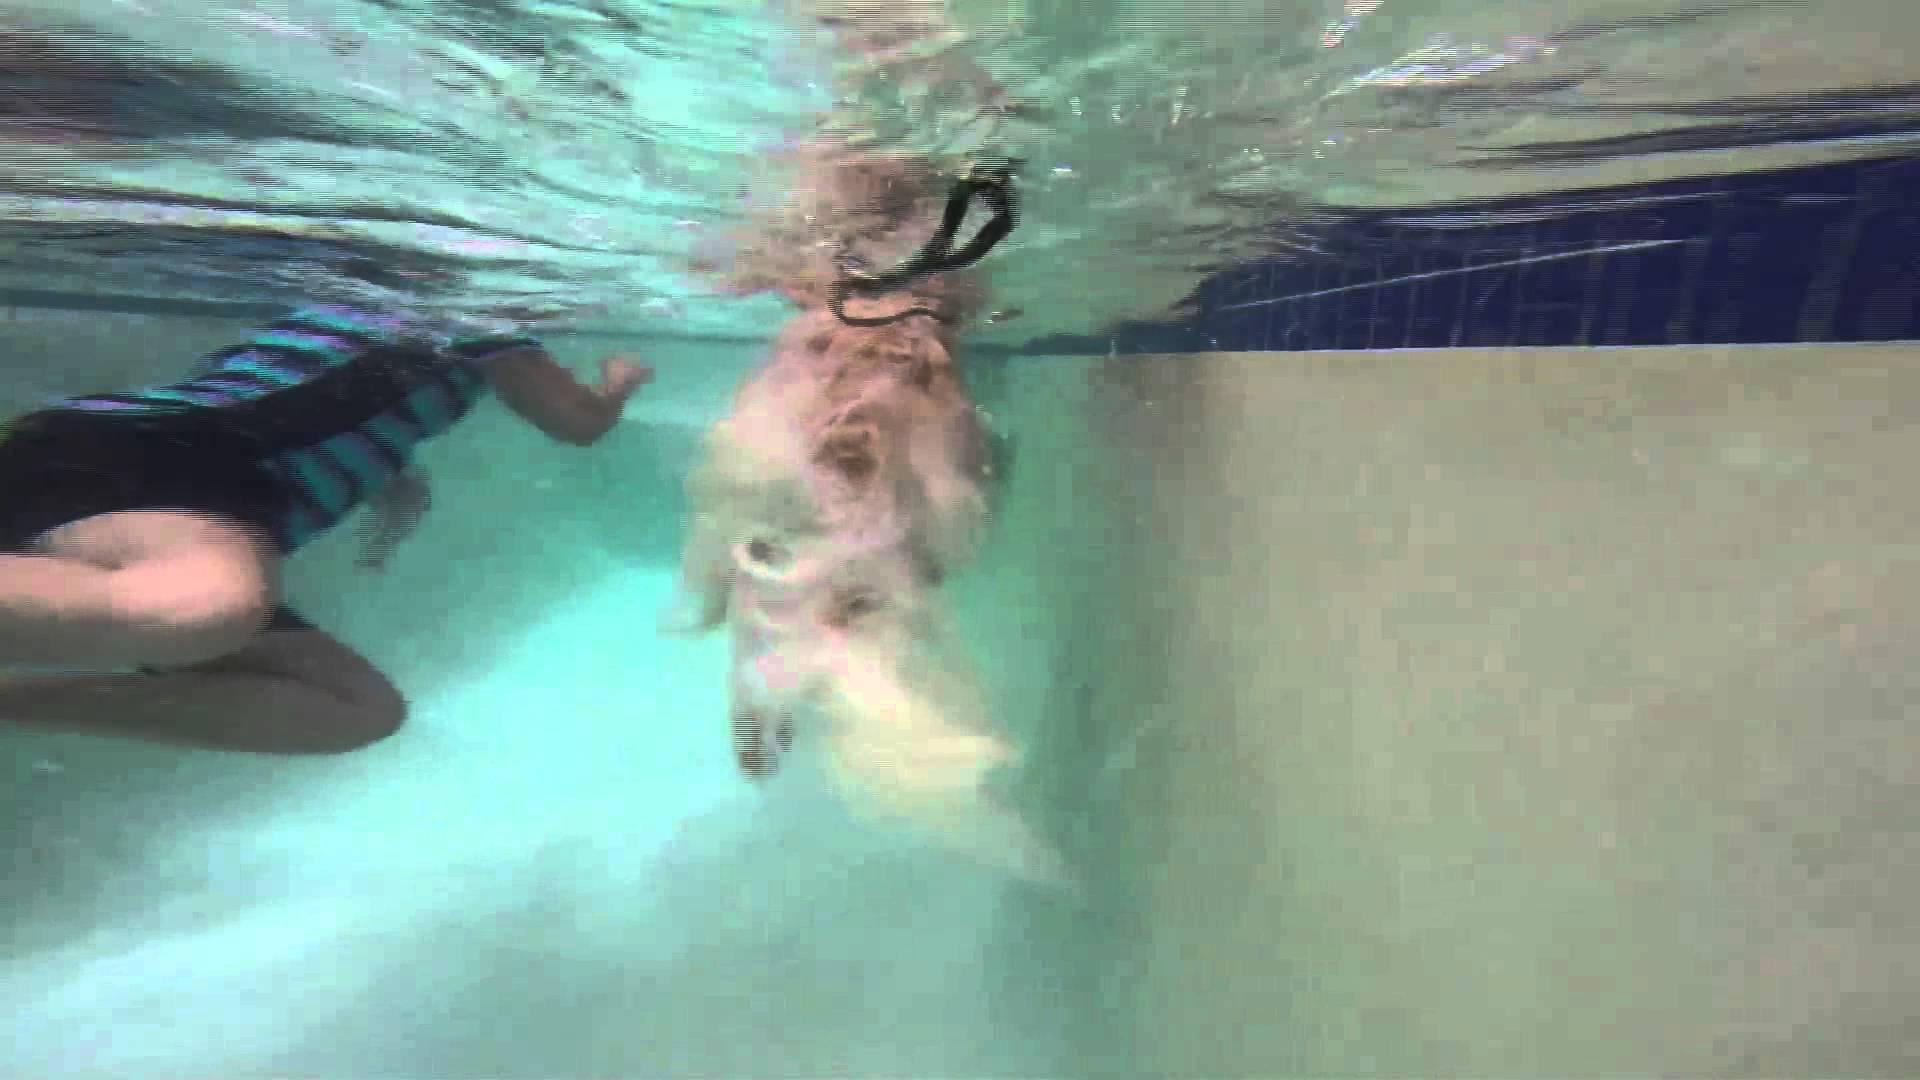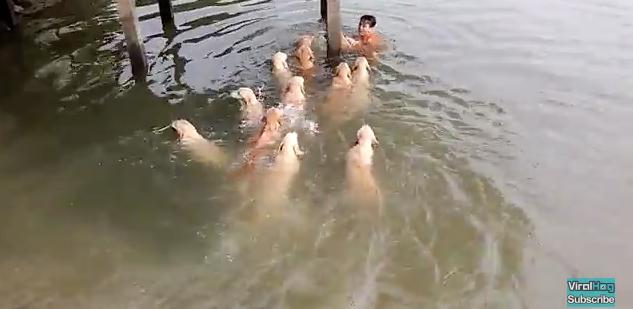The first image is the image on the left, the second image is the image on the right. Analyze the images presented: Is the assertion "In the image on the left a dog is leaping into the air by the water." valid? Answer yes or no. No. The first image is the image on the left, the second image is the image on the right. Considering the images on both sides, is "A single dog is in the water in the image on the right." valid? Answer yes or no. No. 